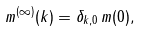Convert formula to latex. <formula><loc_0><loc_0><loc_500><loc_500>m ^ { ( \infty ) } ( { k } ) = \delta _ { k , 0 } \, m ( { 0 } ) ,</formula> 